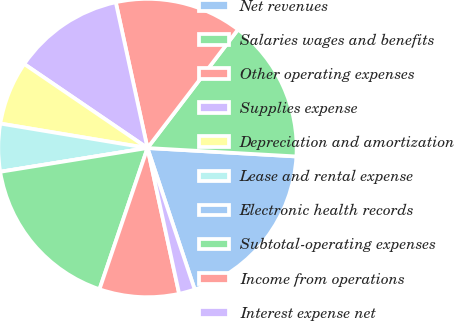<chart> <loc_0><loc_0><loc_500><loc_500><pie_chart><fcel>Net revenues<fcel>Salaries wages and benefits<fcel>Other operating expenses<fcel>Supplies expense<fcel>Depreciation and amortization<fcel>Lease and rental expense<fcel>Electronic health records<fcel>Subtotal-operating expenses<fcel>Income from operations<fcel>Interest expense net<nl><fcel>18.97%<fcel>15.52%<fcel>13.79%<fcel>12.07%<fcel>6.9%<fcel>5.17%<fcel>0.0%<fcel>17.24%<fcel>8.62%<fcel>1.72%<nl></chart> 